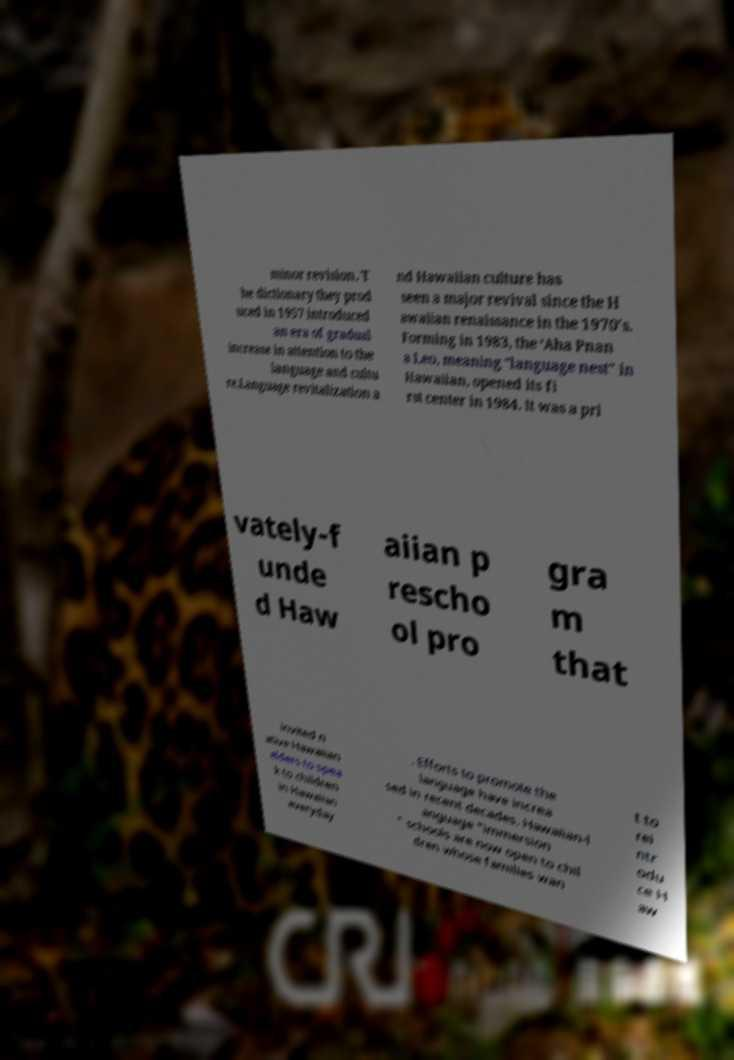I need the written content from this picture converted into text. Can you do that? minor revision. T he dictionary they prod uced in 1957 introduced an era of gradual increase in attention to the language and cultu re.Language revitalization a nd Hawaiian culture has seen a major revival since the H awaiian renaissance in the 1970's. Forming in 1983, the ‘Aha Pnan a Leo, meaning "language nest" in Hawaiian, opened its fi rst center in 1984. It was a pri vately-f unde d Haw aiian p rescho ol pro gra m that invited n ative Hawaiian elders to spea k to children in Hawaiian everyday . Efforts to promote the language have increa sed in recent decades. Hawaiian-l anguage "immersion " schools are now open to chil dren whose families wan t to rei ntr odu ce H aw 